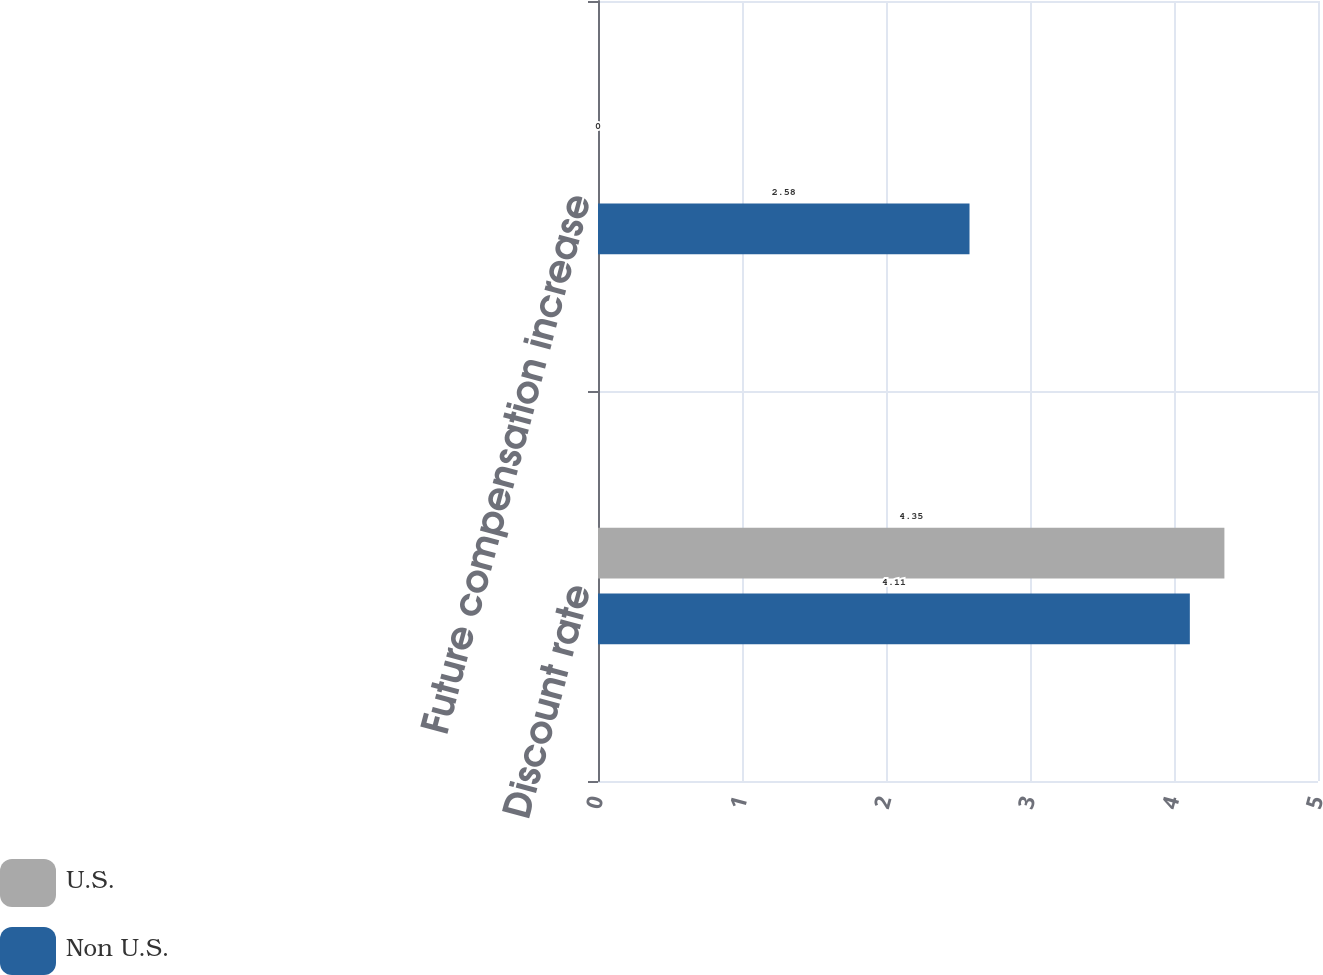Convert chart. <chart><loc_0><loc_0><loc_500><loc_500><stacked_bar_chart><ecel><fcel>Discount rate<fcel>Future compensation increase<nl><fcel>U.S.<fcel>4.35<fcel>0<nl><fcel>Non U.S.<fcel>4.11<fcel>2.58<nl></chart> 